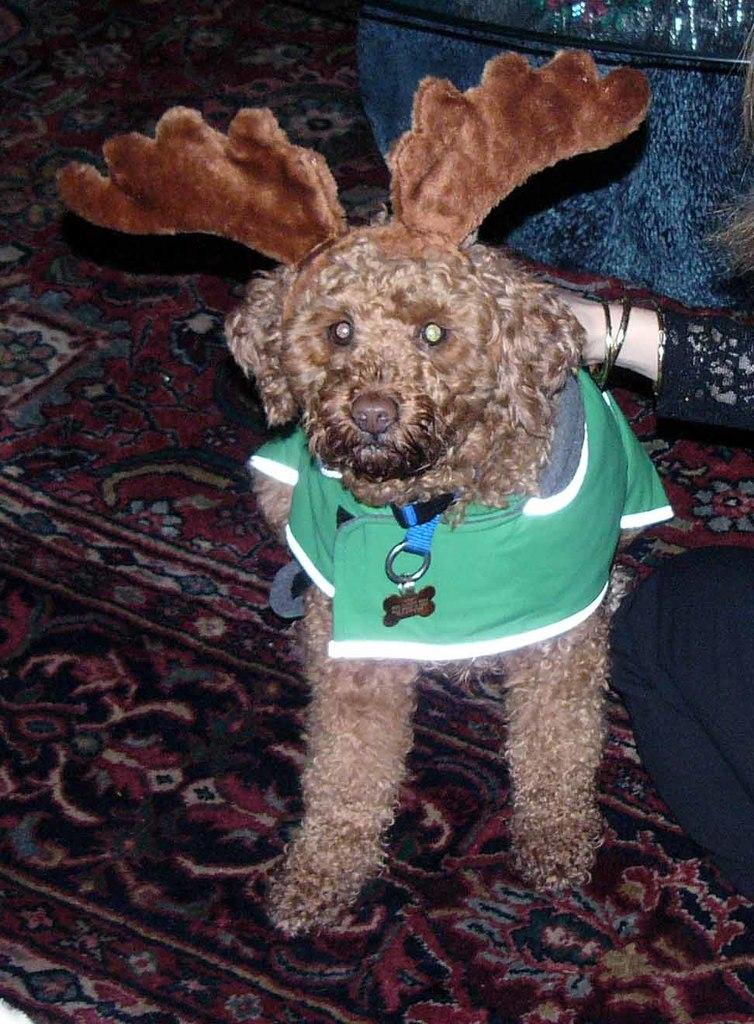What type of animal is present in the image? There is a dog in the image. What is the person in the image doing? The person is sitting on a mat in the image. Where is the shop located in the image? There is no shop present in the image. Is the person swimming in the image? No, the person is sitting on a mat, not swimming. 